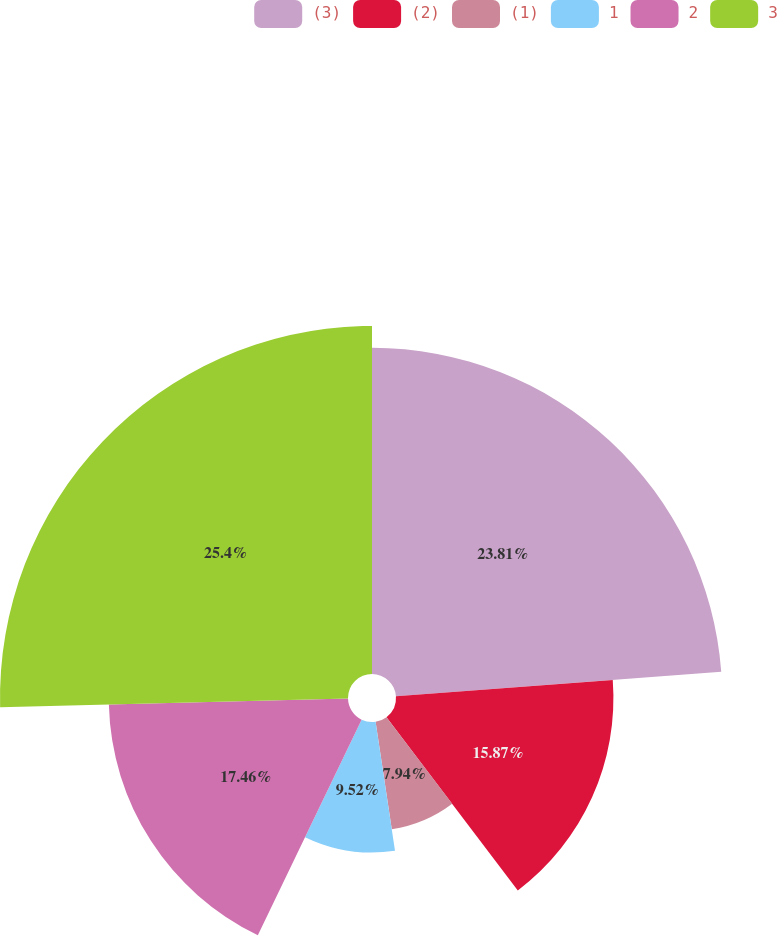Convert chart. <chart><loc_0><loc_0><loc_500><loc_500><pie_chart><fcel>(3)<fcel>(2)<fcel>(1)<fcel>1<fcel>2<fcel>3<nl><fcel>23.81%<fcel>15.87%<fcel>7.94%<fcel>9.52%<fcel>17.46%<fcel>25.4%<nl></chart> 